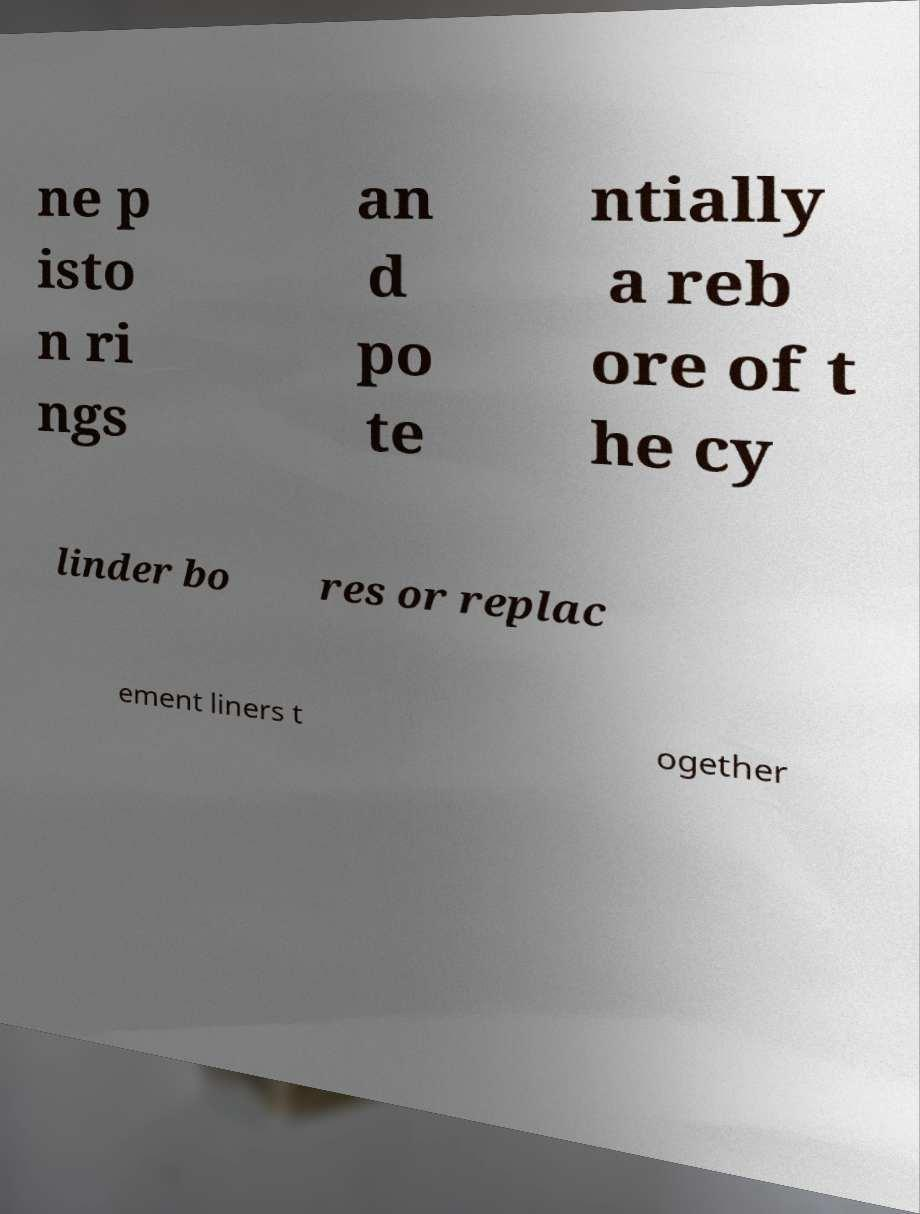For documentation purposes, I need the text within this image transcribed. Could you provide that? ne p isto n ri ngs an d po te ntially a reb ore of t he cy linder bo res or replac ement liners t ogether 